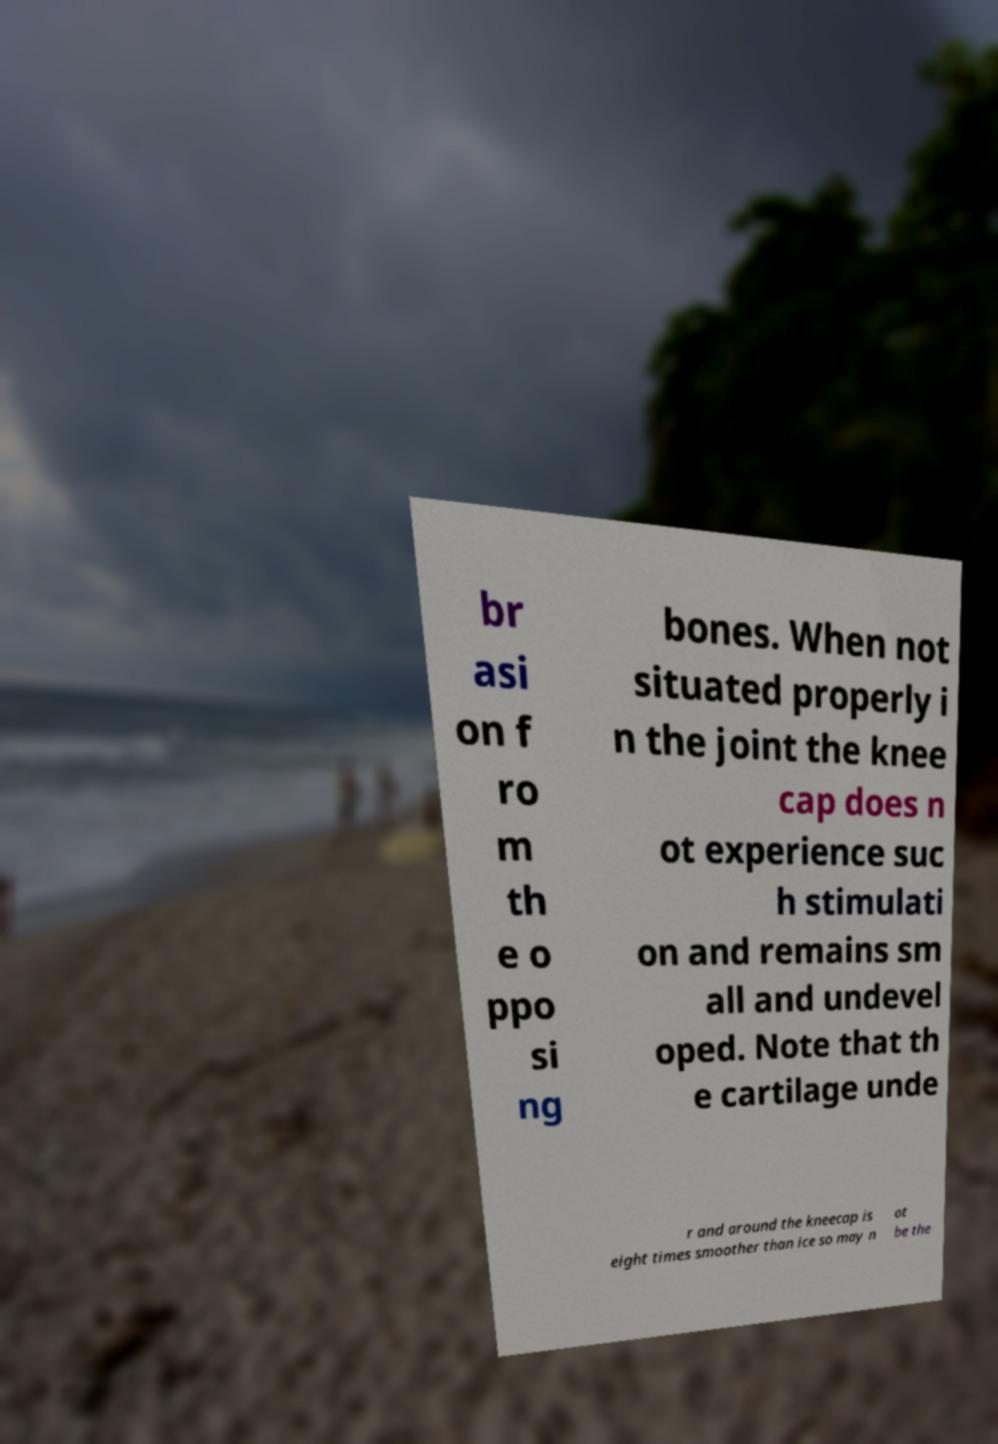There's text embedded in this image that I need extracted. Can you transcribe it verbatim? br asi on f ro m th e o ppo si ng bones. When not situated properly i n the joint the knee cap does n ot experience suc h stimulati on and remains sm all and undevel oped. Note that th e cartilage unde r and around the kneecap is eight times smoother than ice so may n ot be the 